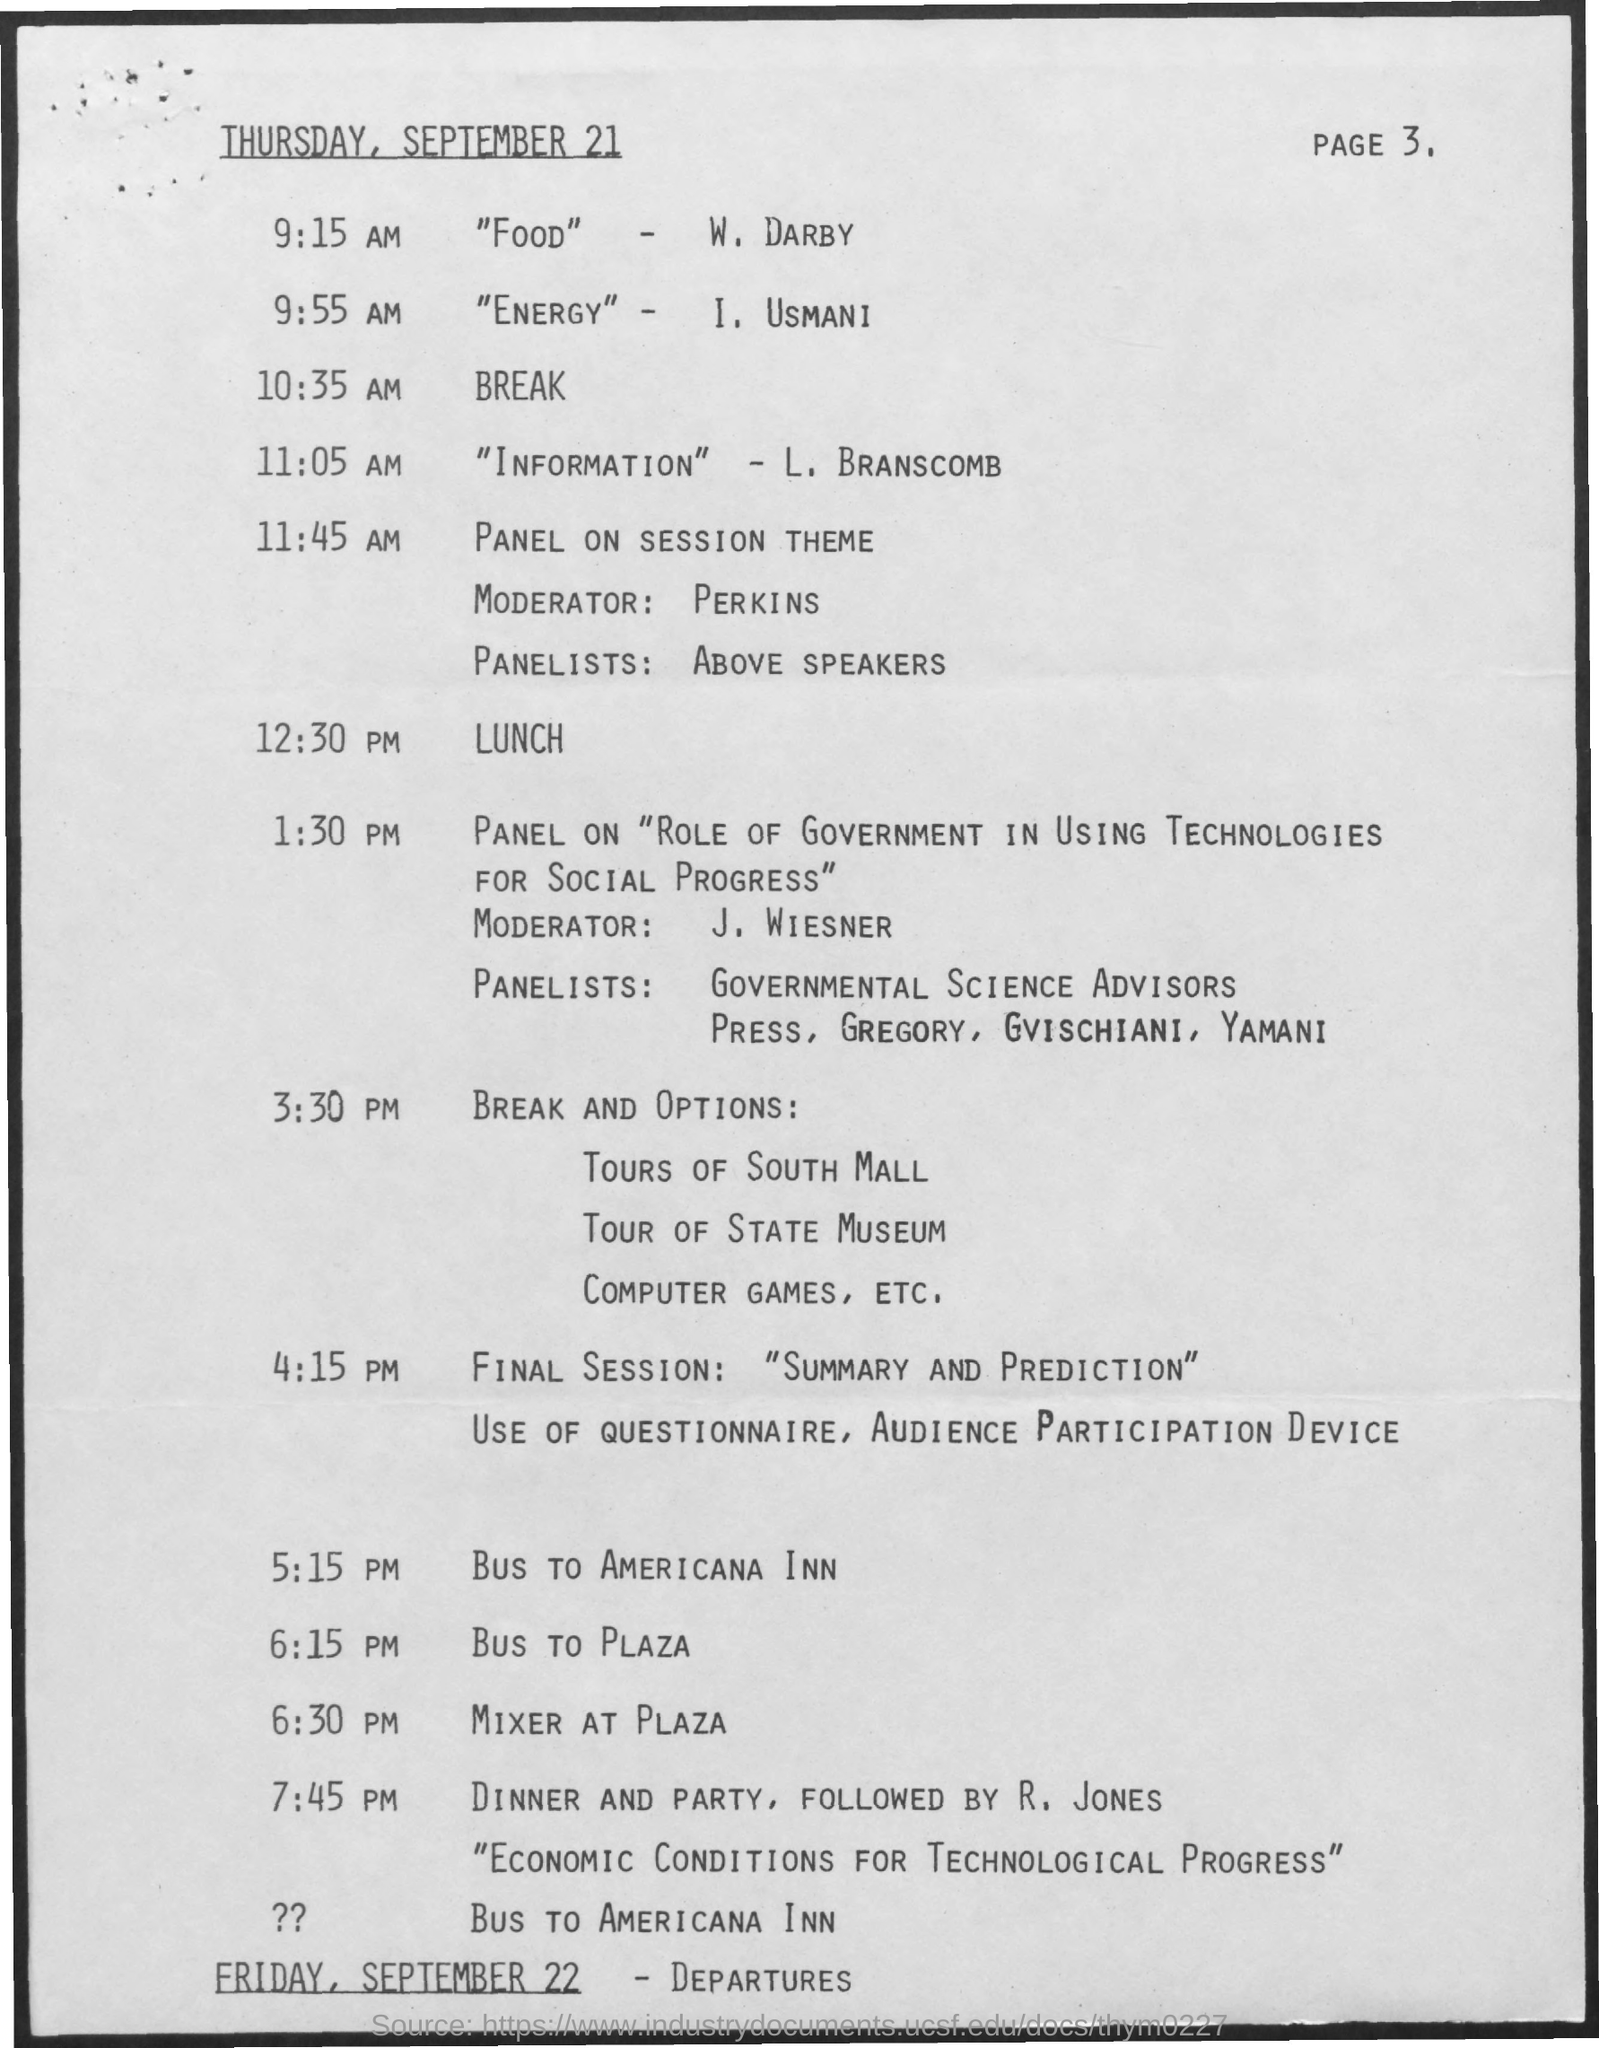Draw attention to some important aspects in this diagram. The presenter is L. Branscomb. Friday, September 22 is the date of the departures. On Thursday, September 21, the break will occur at 10:35 AM. It is currently 12:30 PM and lunch will be served. Usmani is presenting "Energy. 